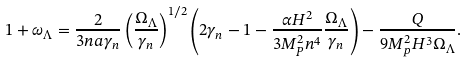Convert formula to latex. <formula><loc_0><loc_0><loc_500><loc_500>1 + \omega _ { \Lambda } = \frac { 2 } { 3 n a \gamma _ { n } } \left ( { \frac { \Omega _ { \Lambda } } { \gamma _ { n } } } \right ) ^ { 1 / 2 } \left ( 2 \gamma _ { n } - 1 - \frac { \alpha H ^ { 2 } } { 3 { M ^ { 2 } _ { P } } n ^ { 4 } } \frac { \Omega _ { \Lambda } } { \gamma _ { n } } \right ) - \frac { Q } { 9 M _ { p } ^ { 2 } H ^ { 3 } \Omega _ { \Lambda } } .</formula> 